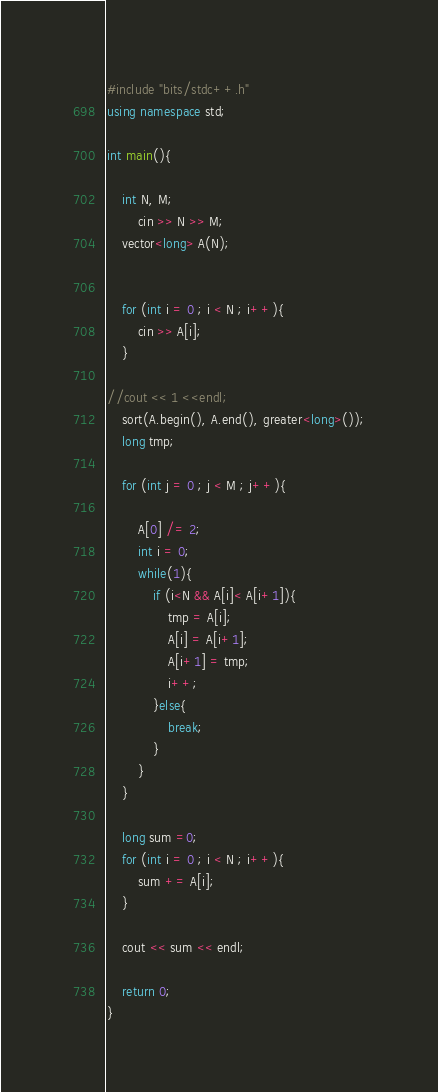Convert code to text. <code><loc_0><loc_0><loc_500><loc_500><_C++_>#include "bits/stdc++.h"
using namespace std;

int main(){

    int N, M;
        cin >> N >> M;
    vector<long> A(N);


    for (int i = 0 ; i < N ; i++){
        cin >> A[i];
    }

//cout << 1 <<endl;
    sort(A.begin(), A.end(), greater<long>());
    long tmp;

    for (int j = 0 ; j < M ; j++){
        
        A[0] /= 2;
        int i = 0;
        while(1){
            if (i<N && A[i]< A[i+1]){
                tmp = A[i];
                A[i] = A[i+1];
                A[i+1] = tmp; 
                i++;
            }else{
                break;
            }
        }
    }

    long sum =0;
    for (int i = 0 ; i < N ; i++){
        sum += A[i];
    }

    cout << sum << endl;

	return 0;
}

</code> 